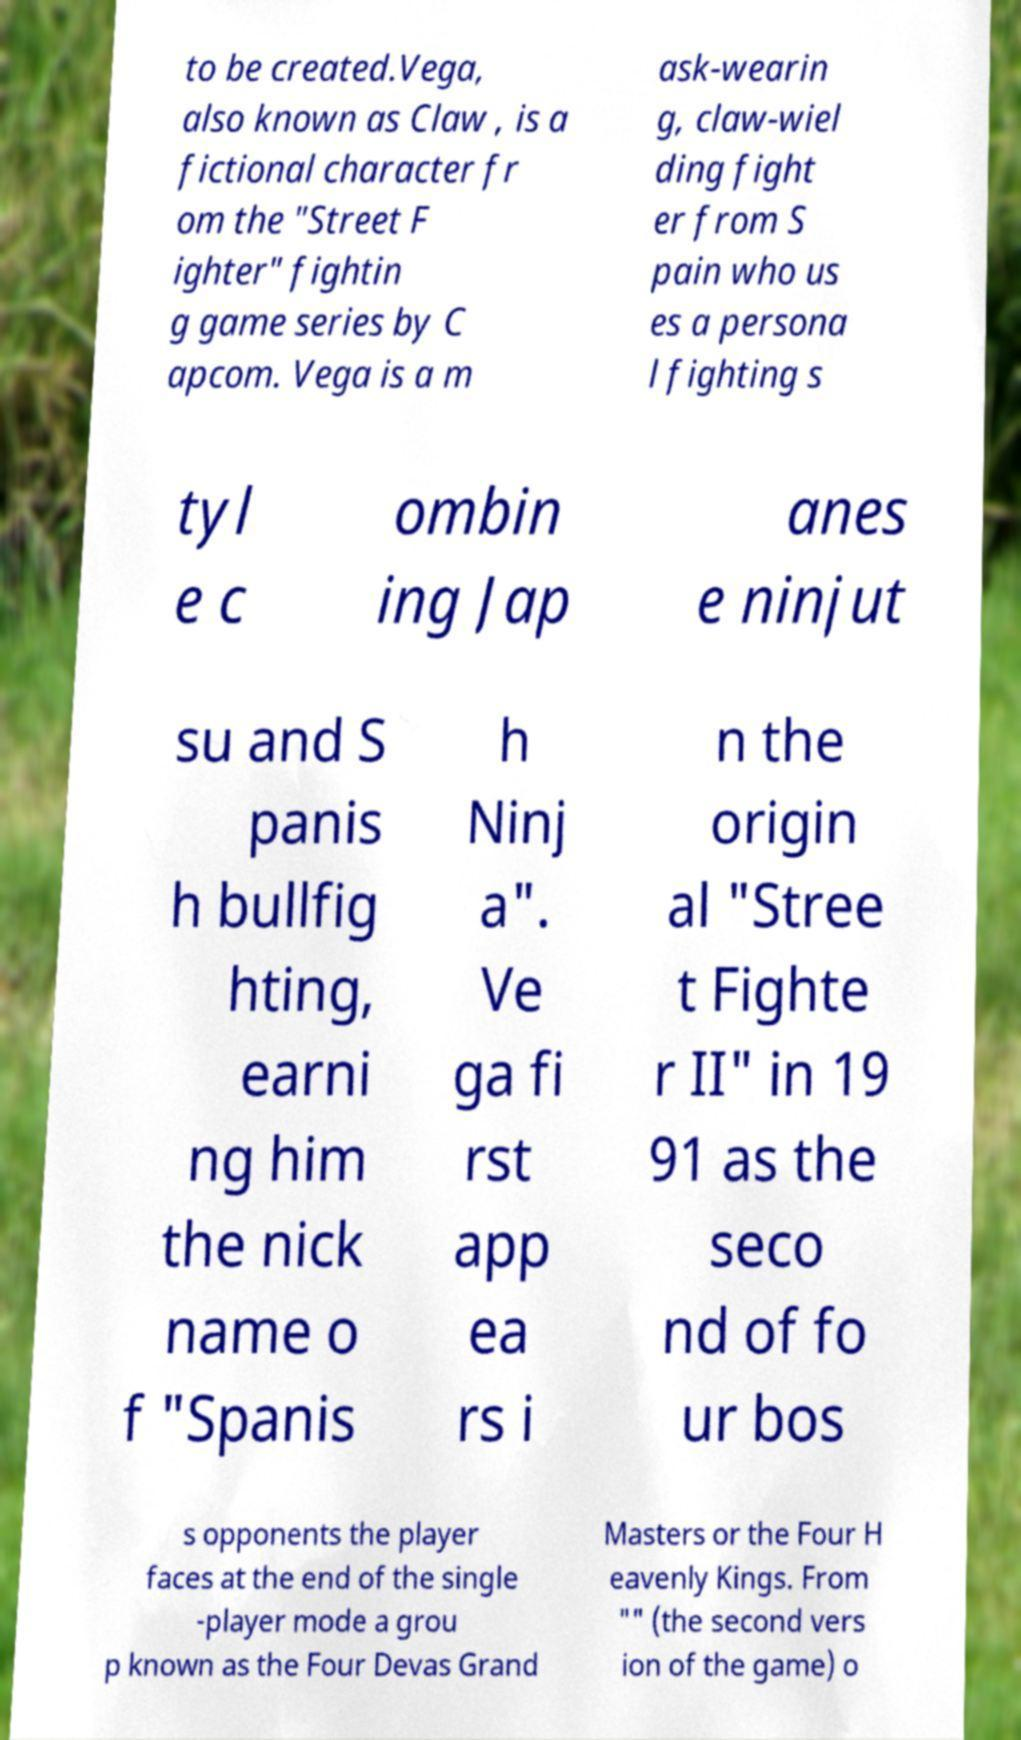I need the written content from this picture converted into text. Can you do that? to be created.Vega, also known as Claw , is a fictional character fr om the "Street F ighter" fightin g game series by C apcom. Vega is a m ask-wearin g, claw-wiel ding fight er from S pain who us es a persona l fighting s tyl e c ombin ing Jap anes e ninjut su and S panis h bullfig hting, earni ng him the nick name o f "Spanis h Ninj a". Ve ga fi rst app ea rs i n the origin al "Stree t Fighte r II" in 19 91 as the seco nd of fo ur bos s opponents the player faces at the end of the single -player mode a grou p known as the Four Devas Grand Masters or the Four H eavenly Kings. From "" (the second vers ion of the game) o 